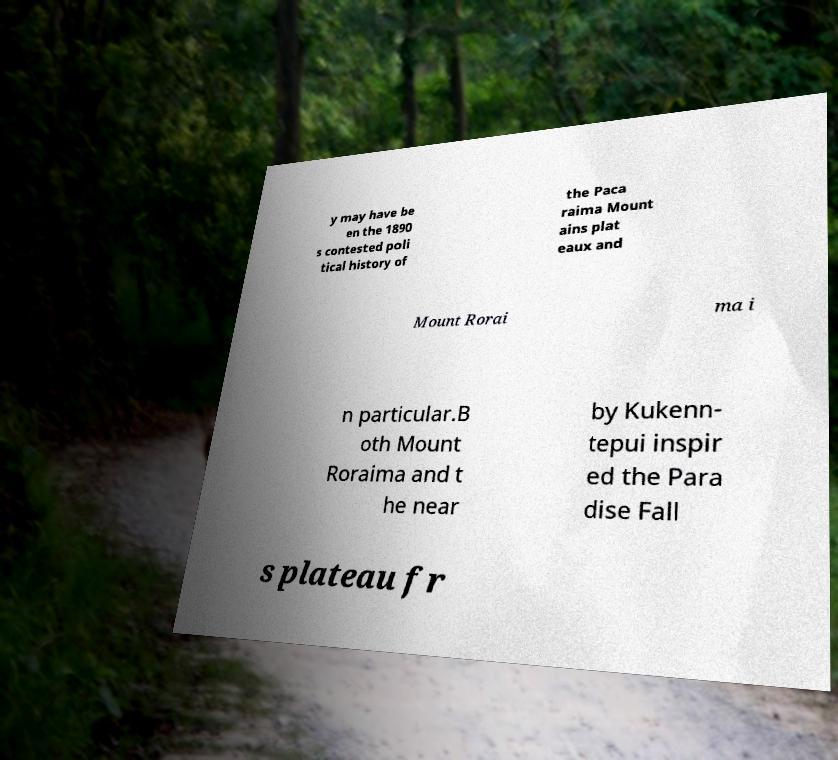I need the written content from this picture converted into text. Can you do that? y may have be en the 1890 s contested poli tical history of the Paca raima Mount ains plat eaux and Mount Rorai ma i n particular.B oth Mount Roraima and t he near by Kukenn- tepui inspir ed the Para dise Fall s plateau fr 